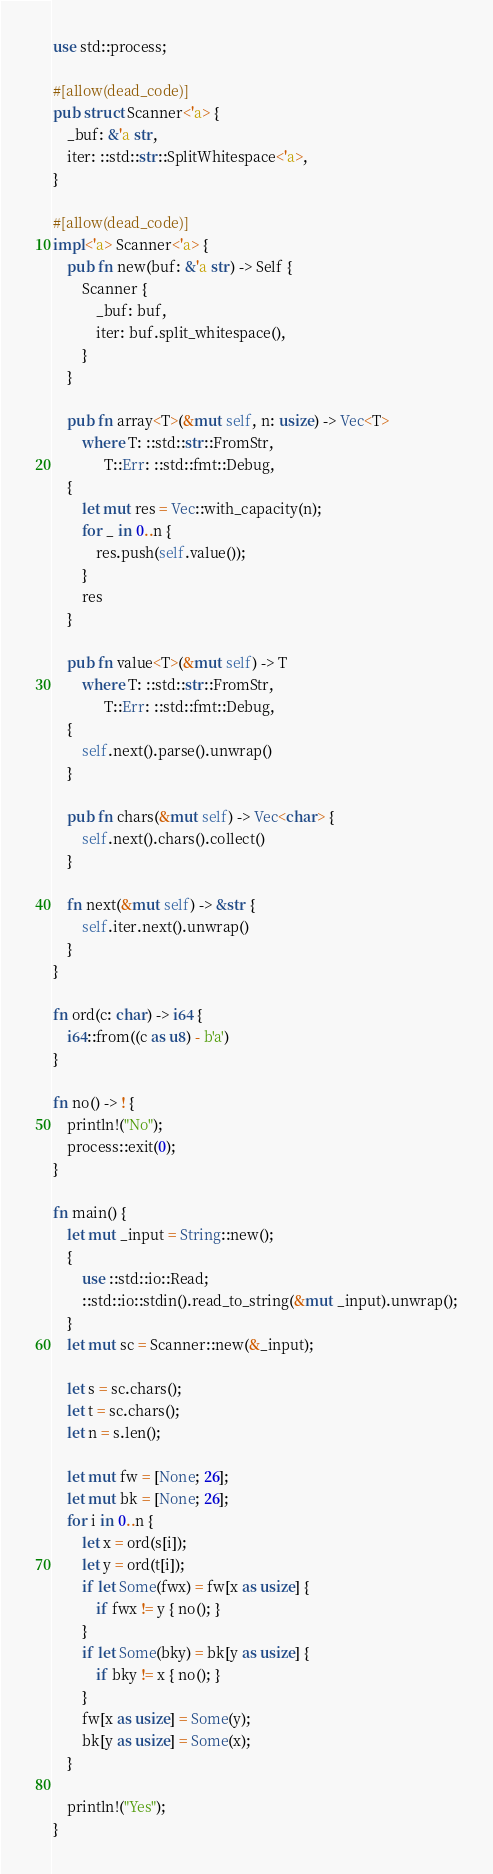Convert code to text. <code><loc_0><loc_0><loc_500><loc_500><_Rust_>use std::process;

#[allow(dead_code)]
pub struct Scanner<'a> {
    _buf: &'a str,
    iter: ::std::str::SplitWhitespace<'a>,
}

#[allow(dead_code)]
impl<'a> Scanner<'a> {
    pub fn new(buf: &'a str) -> Self {
        Scanner {
            _buf: buf,
            iter: buf.split_whitespace(),
        }
    }

    pub fn array<T>(&mut self, n: usize) -> Vec<T>
        where T: ::std::str::FromStr,
              T::Err: ::std::fmt::Debug,
    {
        let mut res = Vec::with_capacity(n);
        for _ in 0..n {
            res.push(self.value());
        }
        res
    }

    pub fn value<T>(&mut self) -> T
        where T: ::std::str::FromStr,
              T::Err: ::std::fmt::Debug,
    {
        self.next().parse().unwrap()
    }

    pub fn chars(&mut self) -> Vec<char> {
        self.next().chars().collect()
    }

    fn next(&mut self) -> &str {
        self.iter.next().unwrap()
    }
}

fn ord(c: char) -> i64 {
    i64::from((c as u8) - b'a')
}

fn no() -> ! {
    println!("No");
    process::exit(0);
}

fn main() {
    let mut _input = String::new();
    {
        use ::std::io::Read;
        ::std::io::stdin().read_to_string(&mut _input).unwrap();
    }
    let mut sc = Scanner::new(&_input);

    let s = sc.chars();
    let t = sc.chars();
    let n = s.len();

    let mut fw = [None; 26];
    let mut bk = [None; 26];
    for i in 0..n {
        let x = ord(s[i]);
        let y = ord(t[i]);
        if let Some(fwx) = fw[x as usize] {
            if fwx != y { no(); }
        }
        if let Some(bky) = bk[y as usize] {
            if bky != x { no(); }
        }
        fw[x as usize] = Some(y);
        bk[y as usize] = Some(x);
    }

    println!("Yes");
}
</code> 